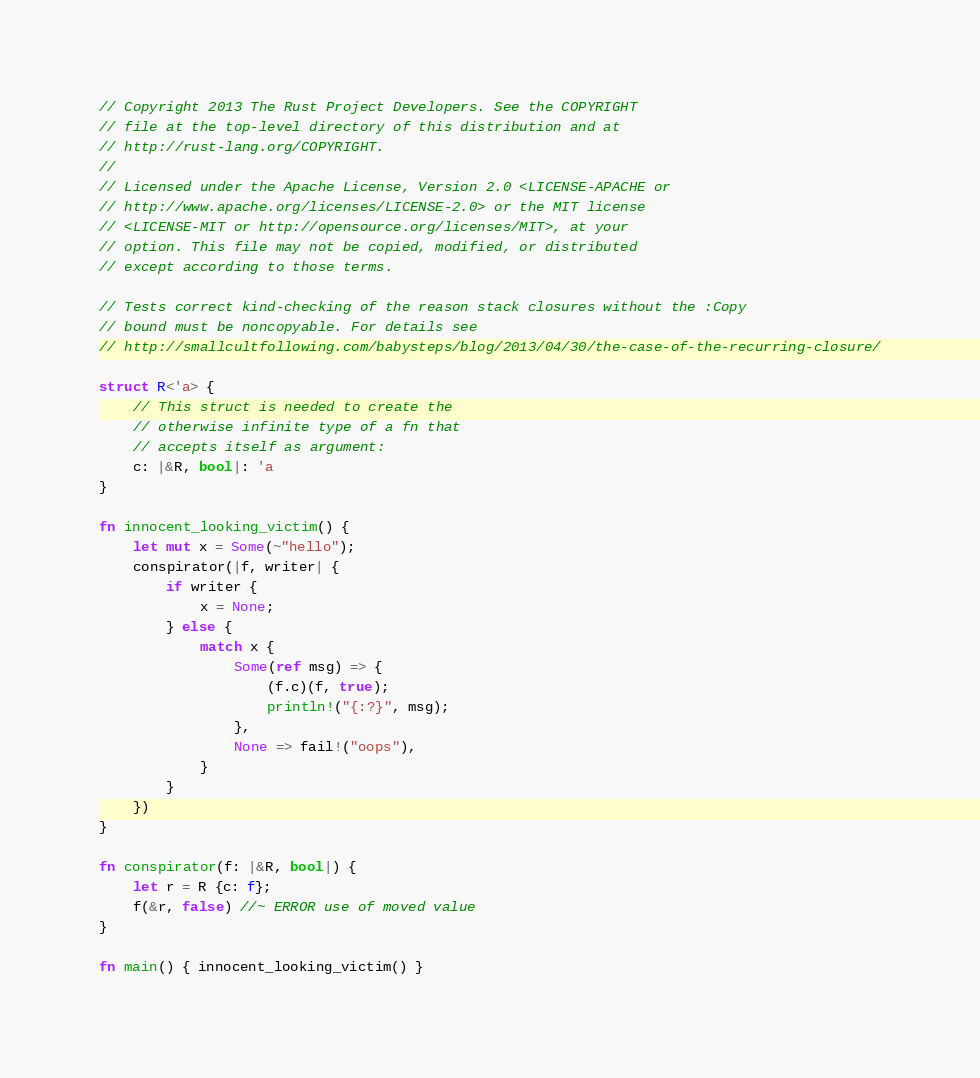<code> <loc_0><loc_0><loc_500><loc_500><_Rust_>// Copyright 2013 The Rust Project Developers. See the COPYRIGHT
// file at the top-level directory of this distribution and at
// http://rust-lang.org/COPYRIGHT.
//
// Licensed under the Apache License, Version 2.0 <LICENSE-APACHE or
// http://www.apache.org/licenses/LICENSE-2.0> or the MIT license
// <LICENSE-MIT or http://opensource.org/licenses/MIT>, at your
// option. This file may not be copied, modified, or distributed
// except according to those terms.

// Tests correct kind-checking of the reason stack closures without the :Copy
// bound must be noncopyable. For details see
// http://smallcultfollowing.com/babysteps/blog/2013/04/30/the-case-of-the-recurring-closure/

struct R<'a> {
    // This struct is needed to create the
    // otherwise infinite type of a fn that
    // accepts itself as argument:
    c: |&R, bool|: 'a
}

fn innocent_looking_victim() {
    let mut x = Some(~"hello");
    conspirator(|f, writer| {
        if writer {
            x = None;
        } else {
            match x {
                Some(ref msg) => {
                    (f.c)(f, true);
                    println!("{:?}", msg);
                },
                None => fail!("oops"),
            }
        }
    })
}

fn conspirator(f: |&R, bool|) {
    let r = R {c: f};
    f(&r, false) //~ ERROR use of moved value
}

fn main() { innocent_looking_victim() }
</code> 